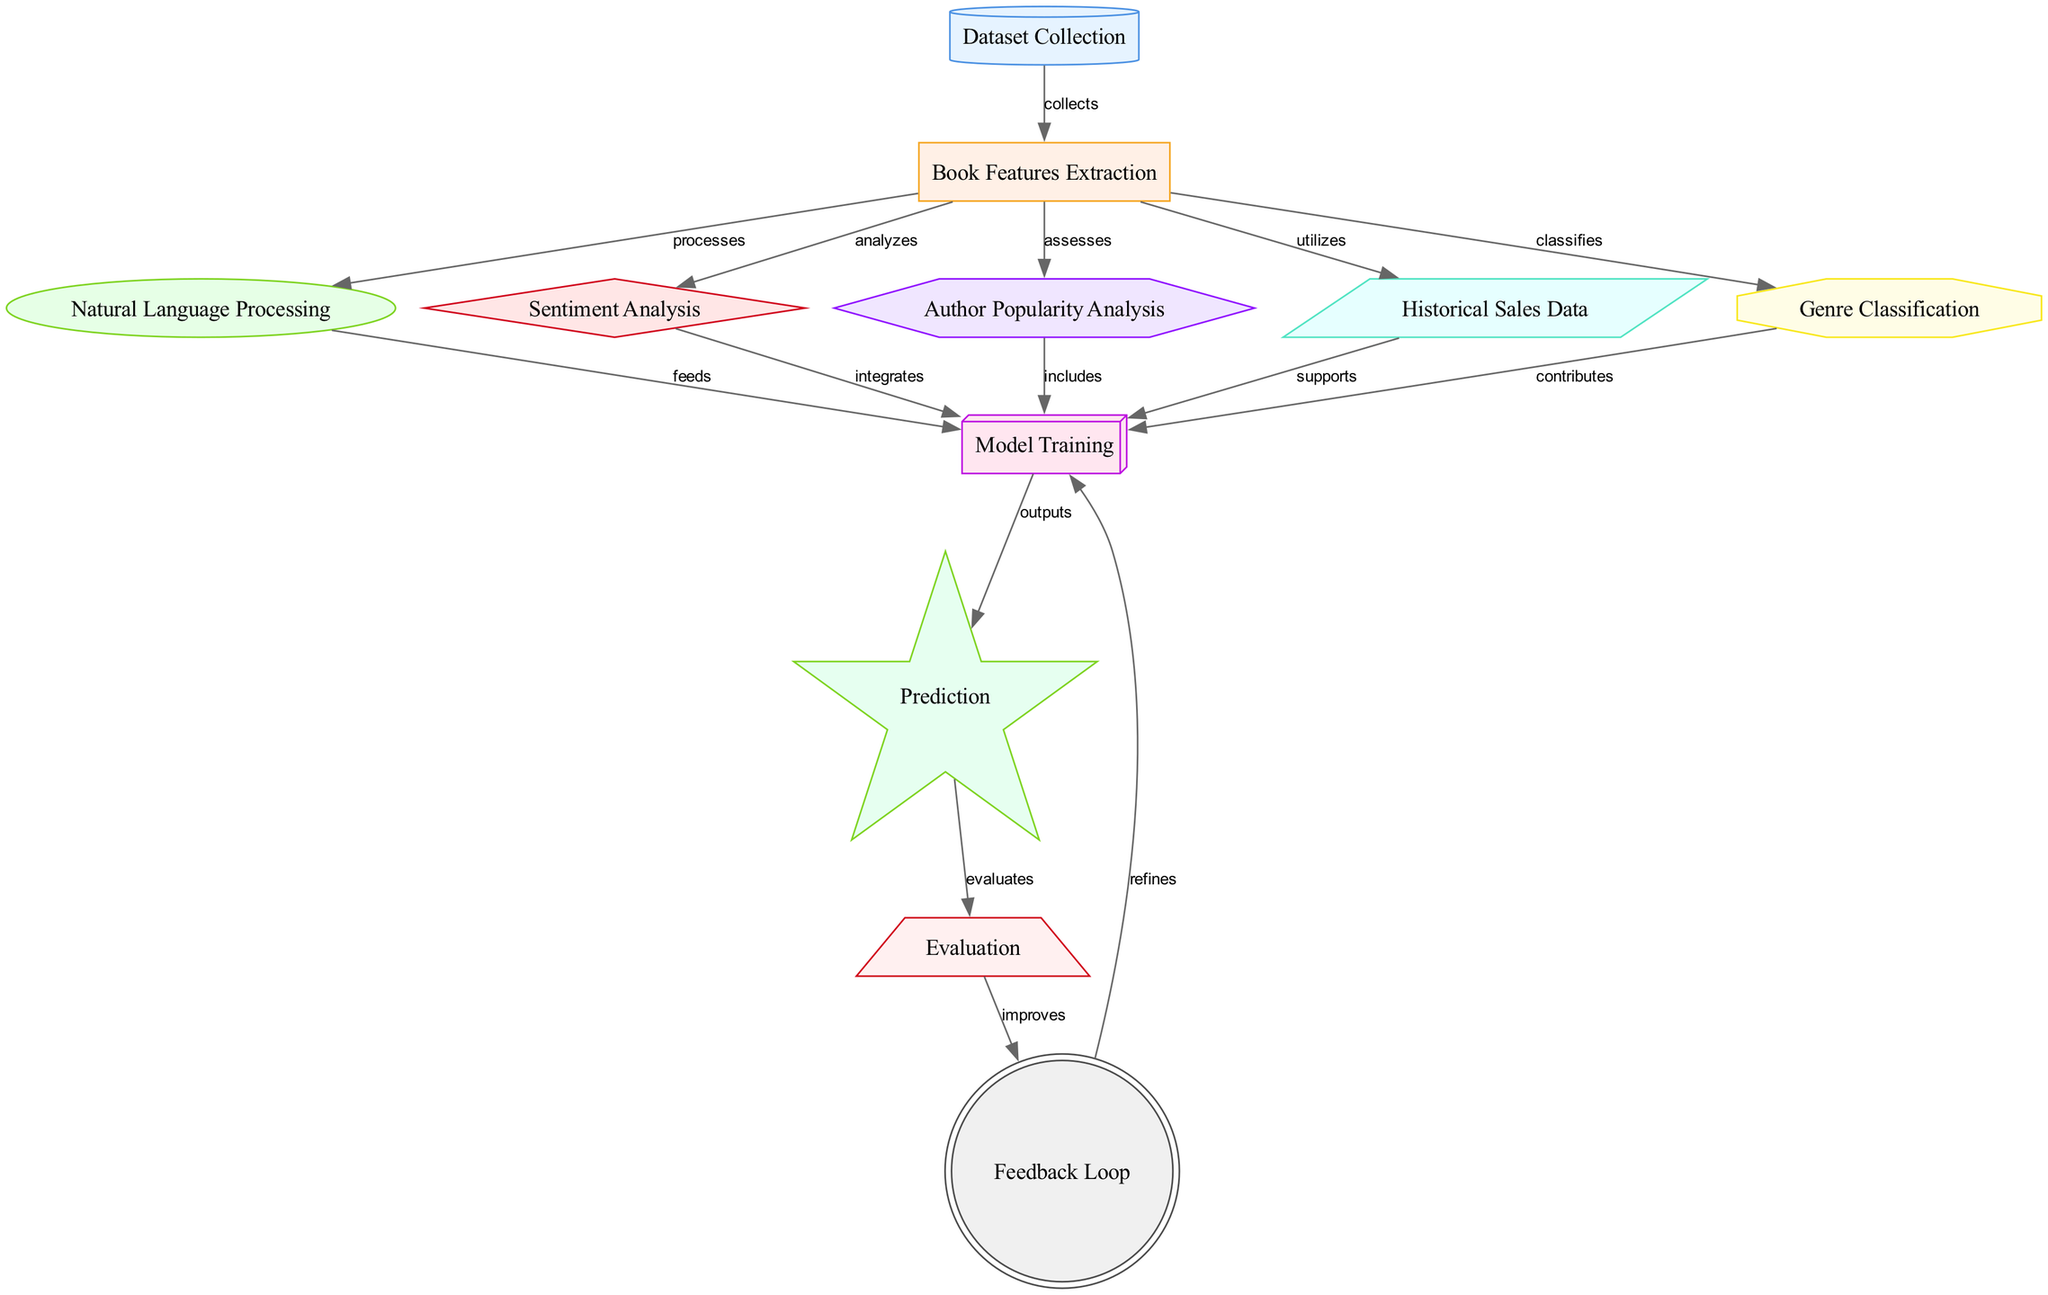What is the first node in the diagram? The first node in the diagram is "Dataset Collection," which starts the process of predicting future bestseller books.
Answer: Dataset Collection How many nodes are in the diagram? The diagram consists of 11 nodes. To arrive at this answer, I counted each unique element within the "nodes" section of the data provided.
Answer: 11 What type of analysis does the "Sentiment Analysis" node perform? The "Sentiment Analysis" node processes the features extracted from the dataset, integrating opinions and emotions to enhance the predictive capabilities of the model.
Answer: Analyzes Which node feeds into the "Model Training" node? The "Natural Language Processing" and "Sentiment Analysis" nodes both feed into the "Model Training" node, indicating that these nodes provide necessary information for training the predictive model.
Answer: Natural Language Processing, Sentiment Analysis What is the final output of the diagram? The final output of the diagram is specified as "Prediction." This indicates the end goal of the entire machine learning process depicted in the diagram.
Answer: Prediction How does the "Feedback Loop" improve the "Model Training" node? The "Feedback Loop" node refines the "Model Training" node by using the evaluation results to make adjustments, ensuring that the model can be improved over time based on its performance.
Answer: Refines What steps are involved immediately before making a prediction? Before making a prediction, several steps need to occur: "Model Training" takes place, which integrates various analyses, and then the trained model outputs its predictions based on the trained data. Thus, it involves analyzing models after training directly before output.
Answer: Model Training and Prediction What does the "Historical Sales Data" node support? The "Historical Sales Data" node supports the "Model Training," by providing relevant historical performance insights that help in developing a more accurate model.
Answer: Model Training 